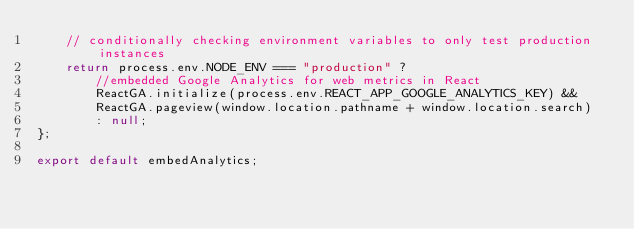<code> <loc_0><loc_0><loc_500><loc_500><_JavaScript_>    // conditionally checking environment variables to only test production instances
    return process.env.NODE_ENV === "production" ?
        //embedded Google Analytics for web metrics in React
        ReactGA.initialize(process.env.REACT_APP_GOOGLE_ANALYTICS_KEY) && 
        ReactGA.pageview(window.location.pathname + window.location.search)
        : null;
};

export default embedAnalytics;
</code> 